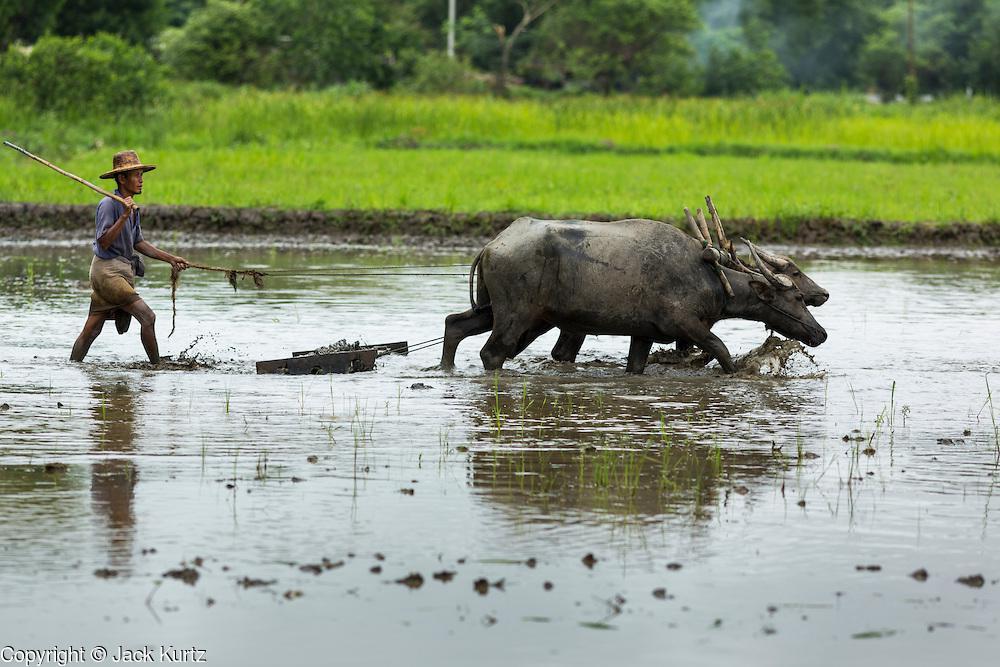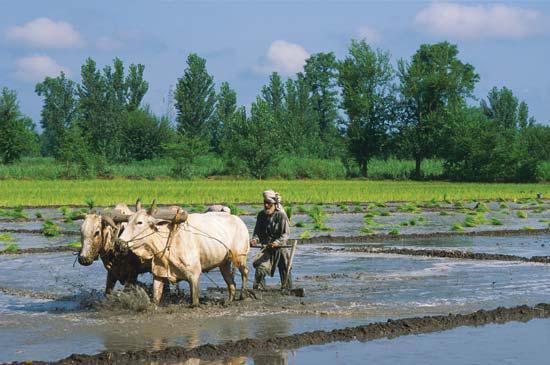The first image is the image on the left, the second image is the image on the right. For the images shown, is this caption "Both images show men behind oxen pulling plows." true? Answer yes or no. Yes. 